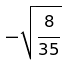<formula> <loc_0><loc_0><loc_500><loc_500>- \sqrt { \frac { 8 } { 3 5 } }</formula> 